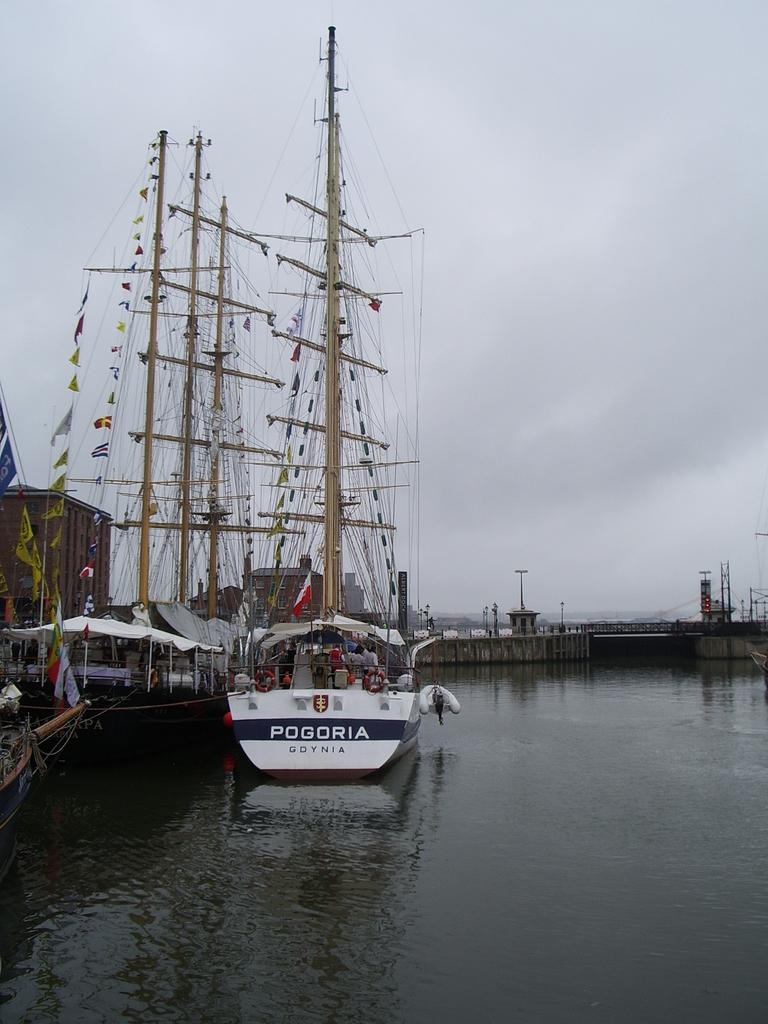What can be seen floating in the water body in the image? There are ships in the water body in the image. What type of structures can be seen in the image? There are buildings visible in the image. What connects the two sides in the image? A walkway bridge is present in the image. What are the flags attached to in the image? Flags are visible in the image, and they are attached to poles. How would you describe the weather in the image? The sky is cloudy in the image. What type of card is being used to open the can in the image? There is no card or can present in the image; it features ships, buildings, a walkway bridge, flags, poles, and a cloudy sky. 